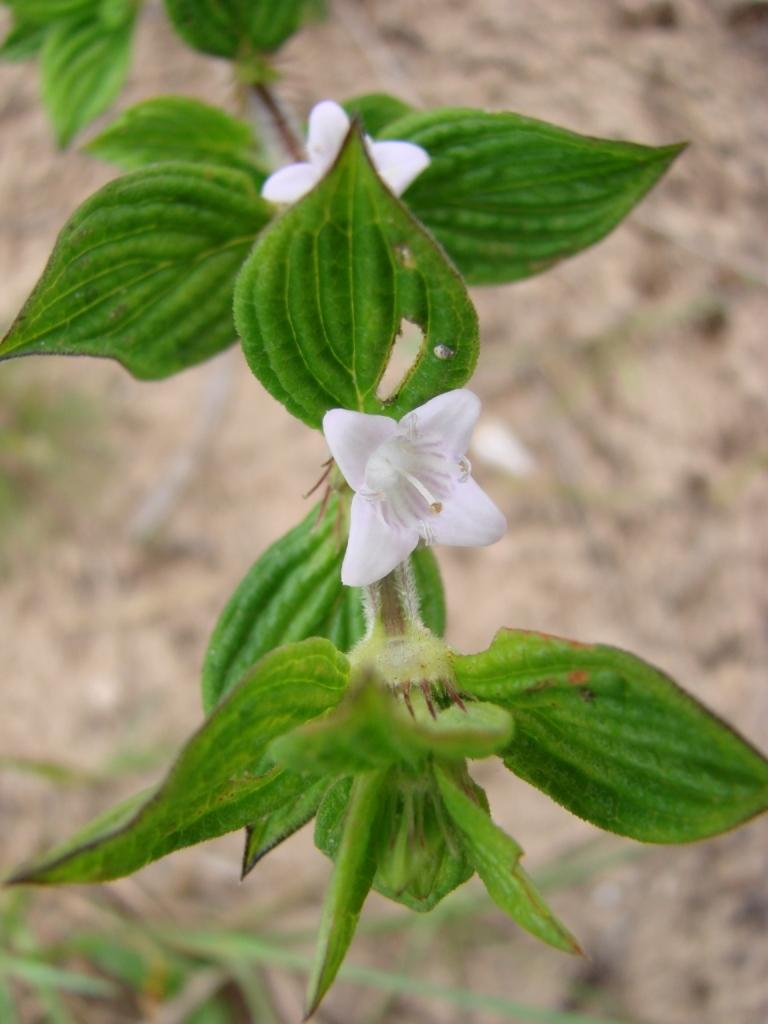What type of flowers are in the center of the image? There are white color flowers in the center of the image. What color are the leaves of the plant? The plant has green leaves. What can be seen in the background of the image? There is ground visible in the background of the image, along with other objects. What type of floor can be seen in the image? There is no floor visible in the image; it features white color flowers and green leaves. What ideas are being discussed in the image? The image does not depict any ideas or discussions; it is a still image of flowers and leaves. 